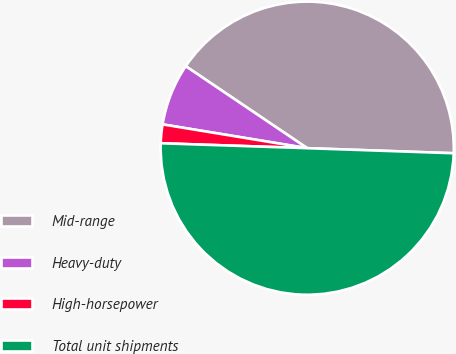Convert chart to OTSL. <chart><loc_0><loc_0><loc_500><loc_500><pie_chart><fcel>Mid-range<fcel>Heavy-duty<fcel>High-horsepower<fcel>Total unit shipments<nl><fcel>41.1%<fcel>6.85%<fcel>2.06%<fcel>49.98%<nl></chart> 